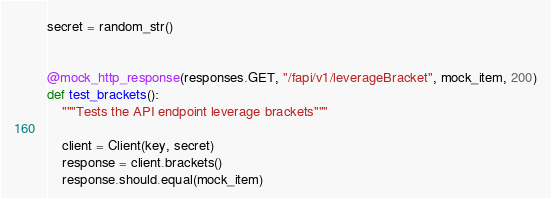Convert code to text. <code><loc_0><loc_0><loc_500><loc_500><_Python_>secret = random_str()


@mock_http_response(responses.GET, "/fapi/v1/leverageBracket", mock_item, 200)
def test_brackets():
    """Tests the API endpoint leverage brackets"""

    client = Client(key, secret)
    response = client.brackets()
    response.should.equal(mock_item)
</code> 